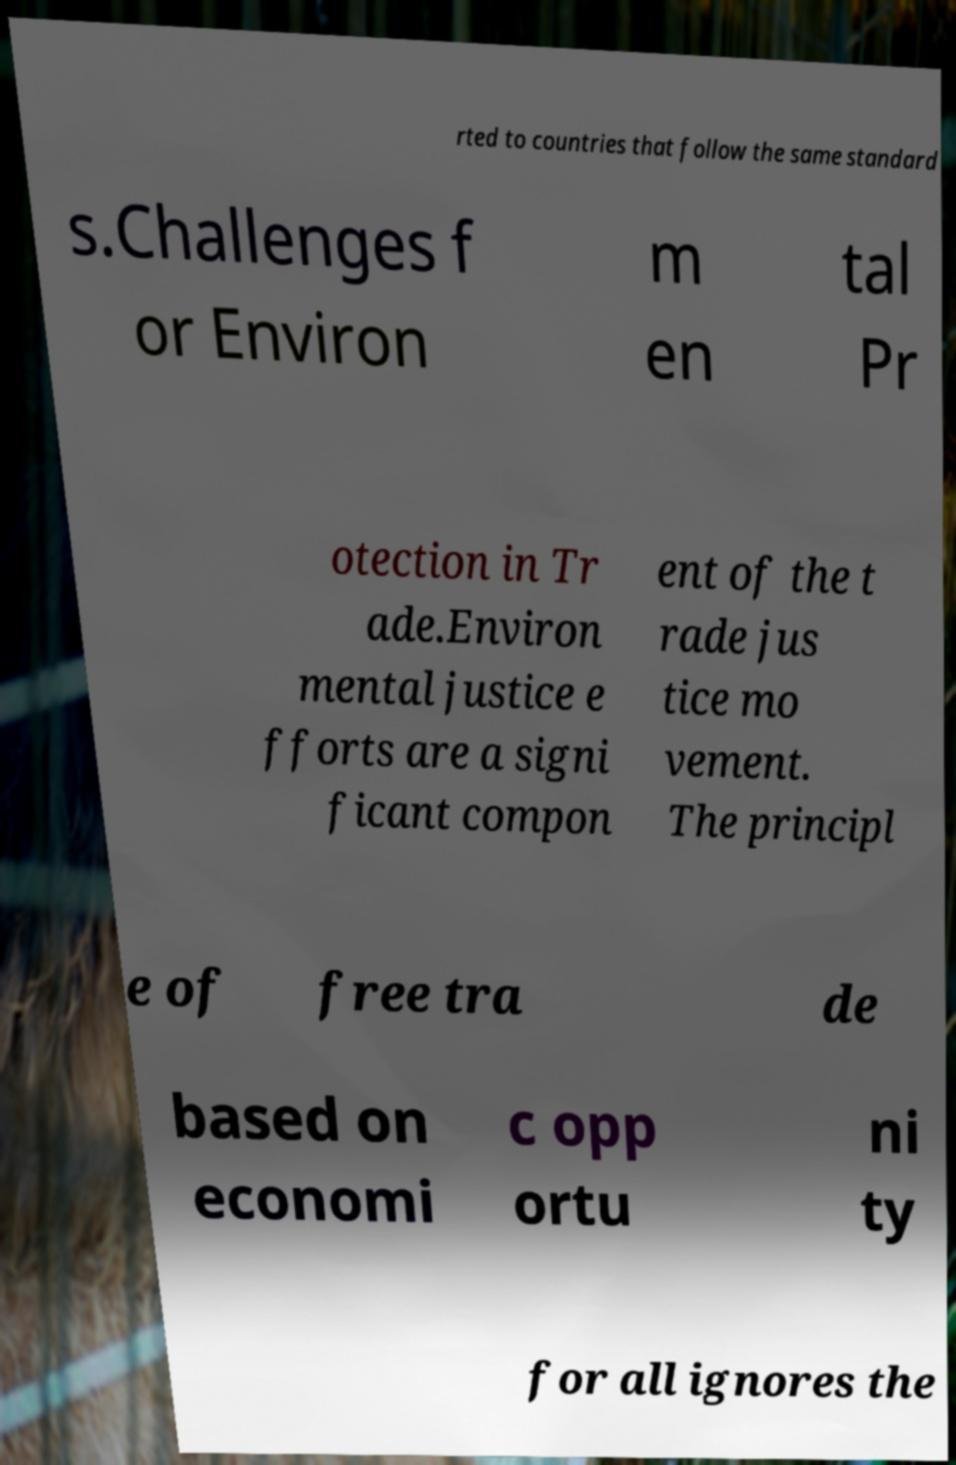Could you extract and type out the text from this image? rted to countries that follow the same standard s.Challenges f or Environ m en tal Pr otection in Tr ade.Environ mental justice e fforts are a signi ficant compon ent of the t rade jus tice mo vement. The principl e of free tra de based on economi c opp ortu ni ty for all ignores the 